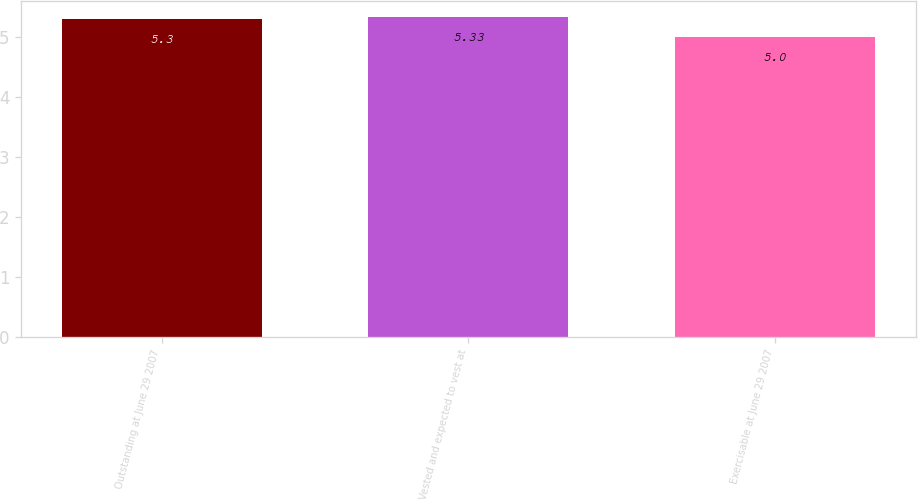<chart> <loc_0><loc_0><loc_500><loc_500><bar_chart><fcel>Outstanding at June 29 2007<fcel>Vested and expected to vest at<fcel>Exercisable at June 29 2007<nl><fcel>5.3<fcel>5.33<fcel>5<nl></chart> 